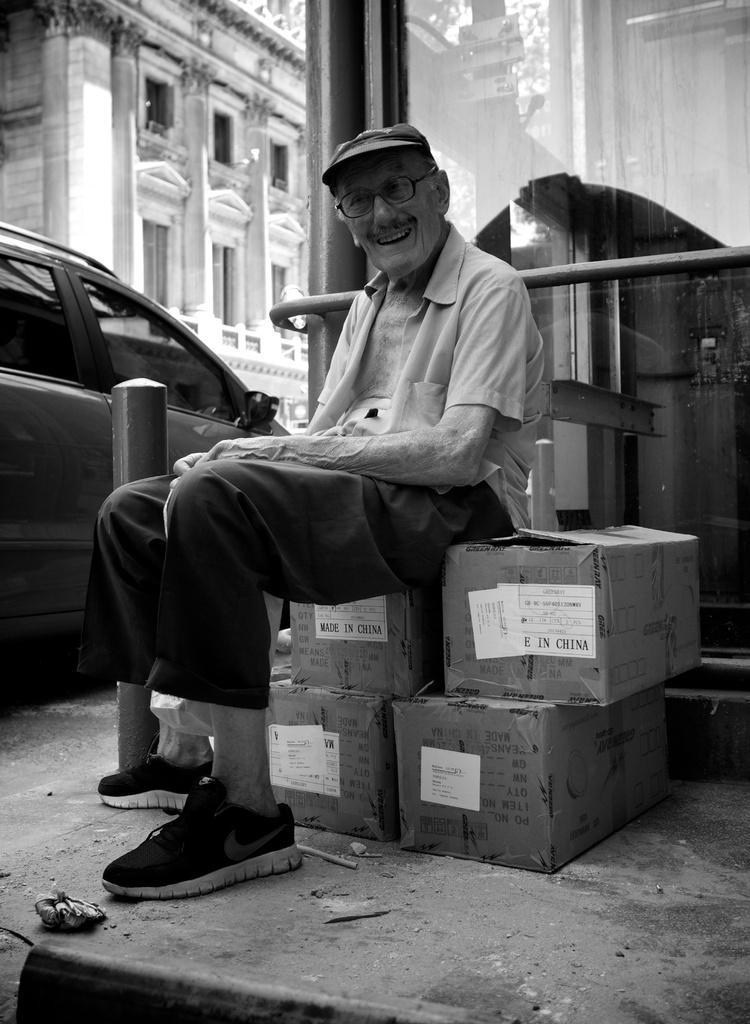In one or two sentences, can you explain what this image depicts? In the image in the center we can see one man sitting on the boxes. In the background there is a building,wall,vehicle,glass etc. 